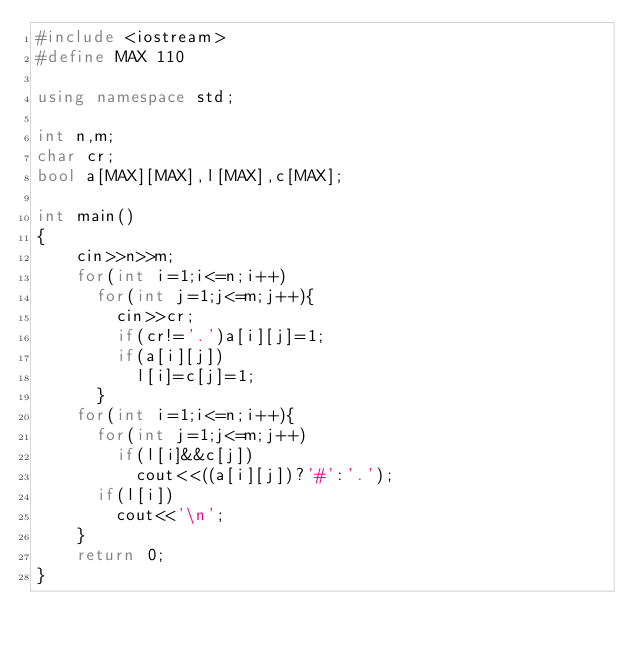Convert code to text. <code><loc_0><loc_0><loc_500><loc_500><_C++_>#include <iostream>
#define MAX 110

using namespace std;

int n,m;
char cr;
bool a[MAX][MAX],l[MAX],c[MAX];

int main()
{
    cin>>n>>m;
    for(int i=1;i<=n;i++)
      for(int j=1;j<=m;j++){
        cin>>cr;
        if(cr!='.')a[i][j]=1;
        if(a[i][j])
          l[i]=c[j]=1;
      }
    for(int i=1;i<=n;i++){
      for(int j=1;j<=m;j++)
        if(l[i]&&c[j])
          cout<<((a[i][j])?'#':'.');
      if(l[i])
        cout<<'\n';
    }
    return 0;
}
</code> 